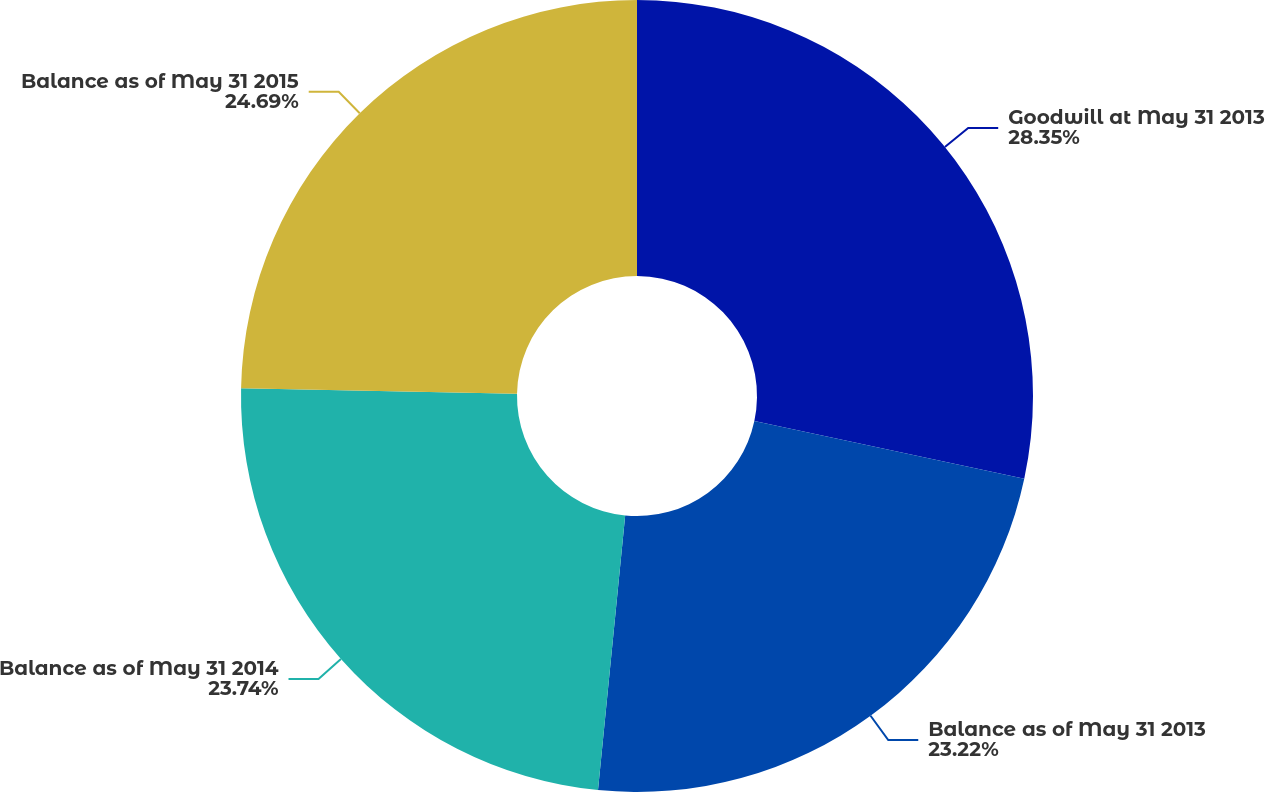Convert chart. <chart><loc_0><loc_0><loc_500><loc_500><pie_chart><fcel>Goodwill at May 31 2013<fcel>Balance as of May 31 2013<fcel>Balance as of May 31 2014<fcel>Balance as of May 31 2015<nl><fcel>28.35%<fcel>23.22%<fcel>23.74%<fcel>24.69%<nl></chart> 